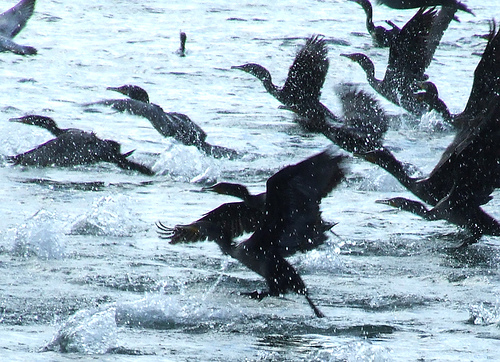Please provide a short description for this region: [0.33, 0.19, 0.41, 0.25]. In this region, we see a 'duck swimming alone.' The image captures the serene moment of a solitary duck gliding through the water. 